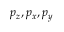<formula> <loc_0><loc_0><loc_500><loc_500>p _ { z } , p _ { x } , p _ { y }</formula> 